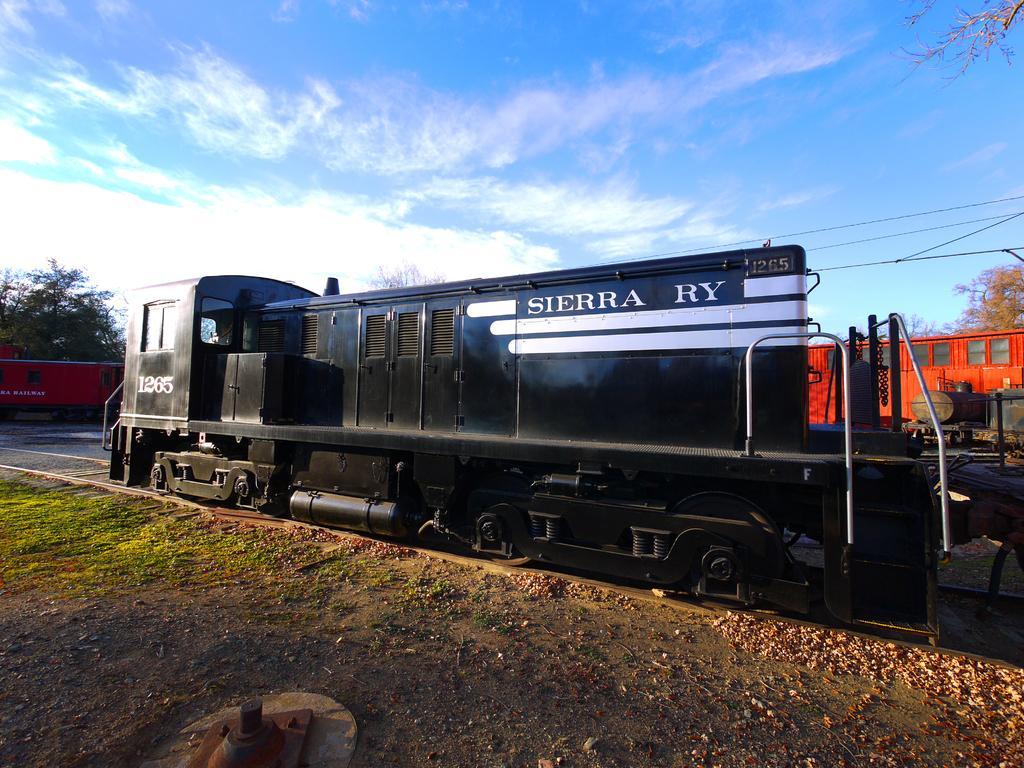Describe this image in one or two sentences. In this image there is the sky truncated towards the top of the image, there are clouds in the sky, there are trees truncated towards the right of the image, there are trees truncated towards the left of the image, there are trees truncated towards the right of the image, there is a railway track truncated, there is text and a number on the train, there is the grass truncated towards the left of the image, there is an object truncated towards the bottom of the image, there are wires truncated towards the right of the image, there is an object truncated towards the left of the image. 